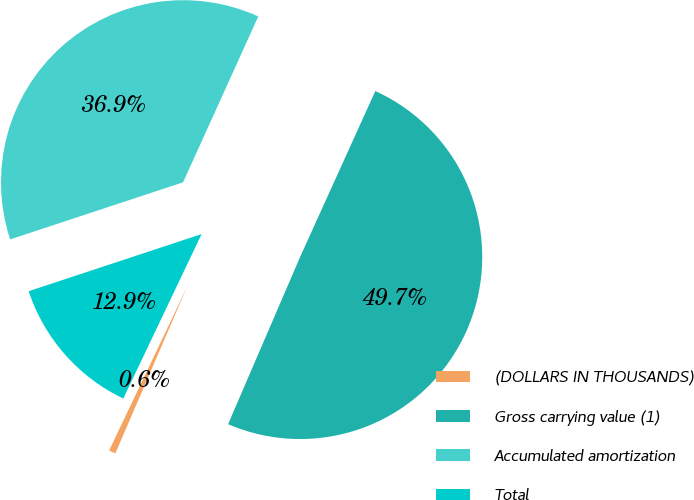Convert chart to OTSL. <chart><loc_0><loc_0><loc_500><loc_500><pie_chart><fcel>(DOLLARS IN THOUSANDS)<fcel>Gross carrying value (1)<fcel>Accumulated amortization<fcel>Total<nl><fcel>0.6%<fcel>49.7%<fcel>36.85%<fcel>12.85%<nl></chart> 